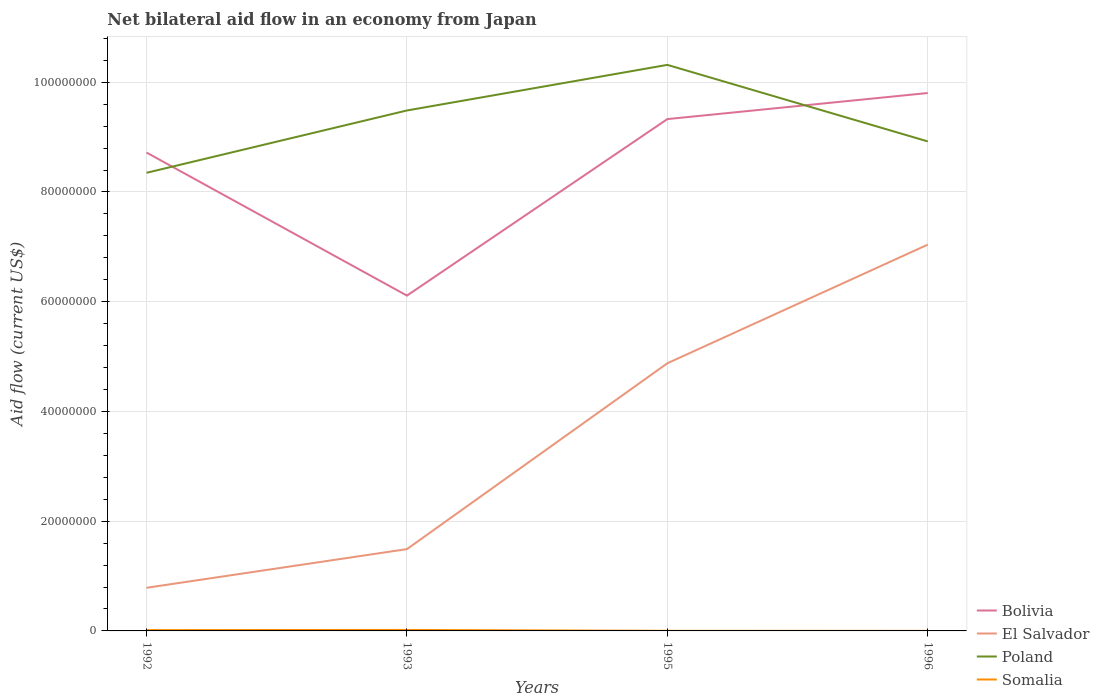Does the line corresponding to Poland intersect with the line corresponding to Bolivia?
Offer a terse response. Yes. Is the number of lines equal to the number of legend labels?
Make the answer very short. Yes. Across all years, what is the maximum net bilateral aid flow in Bolivia?
Provide a short and direct response. 6.11e+07. In which year was the net bilateral aid flow in El Salvador maximum?
Your answer should be compact. 1992. What is the total net bilateral aid flow in Bolivia in the graph?
Your response must be concise. 2.61e+07. What is the difference between the highest and the second highest net bilateral aid flow in Poland?
Your answer should be compact. 1.97e+07. How many lines are there?
Give a very brief answer. 4. Does the graph contain any zero values?
Your answer should be very brief. No. Does the graph contain grids?
Provide a succinct answer. Yes. Where does the legend appear in the graph?
Provide a succinct answer. Bottom right. How are the legend labels stacked?
Make the answer very short. Vertical. What is the title of the graph?
Provide a succinct answer. Net bilateral aid flow in an economy from Japan. What is the label or title of the X-axis?
Keep it short and to the point. Years. What is the label or title of the Y-axis?
Make the answer very short. Aid flow (current US$). What is the Aid flow (current US$) of Bolivia in 1992?
Your answer should be compact. 8.72e+07. What is the Aid flow (current US$) of El Salvador in 1992?
Provide a succinct answer. 7.86e+06. What is the Aid flow (current US$) of Poland in 1992?
Make the answer very short. 8.35e+07. What is the Aid flow (current US$) in Bolivia in 1993?
Provide a succinct answer. 6.11e+07. What is the Aid flow (current US$) in El Salvador in 1993?
Your answer should be compact. 1.49e+07. What is the Aid flow (current US$) in Poland in 1993?
Make the answer very short. 9.48e+07. What is the Aid flow (current US$) of Bolivia in 1995?
Give a very brief answer. 9.33e+07. What is the Aid flow (current US$) of El Salvador in 1995?
Your response must be concise. 4.88e+07. What is the Aid flow (current US$) of Poland in 1995?
Your answer should be very brief. 1.03e+08. What is the Aid flow (current US$) in Bolivia in 1996?
Ensure brevity in your answer.  9.80e+07. What is the Aid flow (current US$) in El Salvador in 1996?
Your answer should be compact. 7.04e+07. What is the Aid flow (current US$) of Poland in 1996?
Offer a terse response. 8.92e+07. Across all years, what is the maximum Aid flow (current US$) in Bolivia?
Offer a very short reply. 9.80e+07. Across all years, what is the maximum Aid flow (current US$) in El Salvador?
Make the answer very short. 7.04e+07. Across all years, what is the maximum Aid flow (current US$) of Poland?
Offer a terse response. 1.03e+08. Across all years, what is the minimum Aid flow (current US$) in Bolivia?
Your response must be concise. 6.11e+07. Across all years, what is the minimum Aid flow (current US$) in El Salvador?
Offer a very short reply. 7.86e+06. Across all years, what is the minimum Aid flow (current US$) in Poland?
Offer a very short reply. 8.35e+07. What is the total Aid flow (current US$) of Bolivia in the graph?
Your answer should be compact. 3.40e+08. What is the total Aid flow (current US$) of El Salvador in the graph?
Offer a terse response. 1.42e+08. What is the total Aid flow (current US$) in Poland in the graph?
Provide a succinct answer. 3.71e+08. What is the difference between the Aid flow (current US$) in Bolivia in 1992 and that in 1993?
Keep it short and to the point. 2.61e+07. What is the difference between the Aid flow (current US$) in El Salvador in 1992 and that in 1993?
Your answer should be very brief. -7.05e+06. What is the difference between the Aid flow (current US$) in Poland in 1992 and that in 1993?
Provide a short and direct response. -1.14e+07. What is the difference between the Aid flow (current US$) of Somalia in 1992 and that in 1993?
Provide a short and direct response. -3.00e+04. What is the difference between the Aid flow (current US$) of Bolivia in 1992 and that in 1995?
Provide a succinct answer. -6.10e+06. What is the difference between the Aid flow (current US$) of El Salvador in 1992 and that in 1995?
Offer a very short reply. -4.09e+07. What is the difference between the Aid flow (current US$) of Poland in 1992 and that in 1995?
Ensure brevity in your answer.  -1.97e+07. What is the difference between the Aid flow (current US$) in Bolivia in 1992 and that in 1996?
Offer a very short reply. -1.08e+07. What is the difference between the Aid flow (current US$) of El Salvador in 1992 and that in 1996?
Make the answer very short. -6.25e+07. What is the difference between the Aid flow (current US$) of Poland in 1992 and that in 1996?
Ensure brevity in your answer.  -5.72e+06. What is the difference between the Aid flow (current US$) of Bolivia in 1993 and that in 1995?
Give a very brief answer. -3.22e+07. What is the difference between the Aid flow (current US$) in El Salvador in 1993 and that in 1995?
Ensure brevity in your answer.  -3.39e+07. What is the difference between the Aid flow (current US$) of Poland in 1993 and that in 1995?
Your response must be concise. -8.31e+06. What is the difference between the Aid flow (current US$) in Somalia in 1993 and that in 1995?
Make the answer very short. 1.60e+05. What is the difference between the Aid flow (current US$) in Bolivia in 1993 and that in 1996?
Your answer should be compact. -3.69e+07. What is the difference between the Aid flow (current US$) in El Salvador in 1993 and that in 1996?
Offer a very short reply. -5.55e+07. What is the difference between the Aid flow (current US$) of Poland in 1993 and that in 1996?
Provide a short and direct response. 5.64e+06. What is the difference between the Aid flow (current US$) of Somalia in 1993 and that in 1996?
Ensure brevity in your answer.  1.70e+05. What is the difference between the Aid flow (current US$) in Bolivia in 1995 and that in 1996?
Offer a very short reply. -4.75e+06. What is the difference between the Aid flow (current US$) of El Salvador in 1995 and that in 1996?
Give a very brief answer. -2.16e+07. What is the difference between the Aid flow (current US$) of Poland in 1995 and that in 1996?
Offer a very short reply. 1.40e+07. What is the difference between the Aid flow (current US$) in Bolivia in 1992 and the Aid flow (current US$) in El Salvador in 1993?
Your response must be concise. 7.23e+07. What is the difference between the Aid flow (current US$) of Bolivia in 1992 and the Aid flow (current US$) of Poland in 1993?
Keep it short and to the point. -7.67e+06. What is the difference between the Aid flow (current US$) in Bolivia in 1992 and the Aid flow (current US$) in Somalia in 1993?
Make the answer very short. 8.70e+07. What is the difference between the Aid flow (current US$) in El Salvador in 1992 and the Aid flow (current US$) in Poland in 1993?
Your answer should be very brief. -8.70e+07. What is the difference between the Aid flow (current US$) in El Salvador in 1992 and the Aid flow (current US$) in Somalia in 1993?
Offer a very short reply. 7.68e+06. What is the difference between the Aid flow (current US$) in Poland in 1992 and the Aid flow (current US$) in Somalia in 1993?
Your answer should be compact. 8.33e+07. What is the difference between the Aid flow (current US$) of Bolivia in 1992 and the Aid flow (current US$) of El Salvador in 1995?
Ensure brevity in your answer.  3.84e+07. What is the difference between the Aid flow (current US$) of Bolivia in 1992 and the Aid flow (current US$) of Poland in 1995?
Your answer should be very brief. -1.60e+07. What is the difference between the Aid flow (current US$) of Bolivia in 1992 and the Aid flow (current US$) of Somalia in 1995?
Provide a succinct answer. 8.72e+07. What is the difference between the Aid flow (current US$) in El Salvador in 1992 and the Aid flow (current US$) in Poland in 1995?
Provide a short and direct response. -9.53e+07. What is the difference between the Aid flow (current US$) in El Salvador in 1992 and the Aid flow (current US$) in Somalia in 1995?
Your answer should be very brief. 7.84e+06. What is the difference between the Aid flow (current US$) in Poland in 1992 and the Aid flow (current US$) in Somalia in 1995?
Offer a terse response. 8.35e+07. What is the difference between the Aid flow (current US$) of Bolivia in 1992 and the Aid flow (current US$) of El Salvador in 1996?
Provide a succinct answer. 1.68e+07. What is the difference between the Aid flow (current US$) of Bolivia in 1992 and the Aid flow (current US$) of Poland in 1996?
Provide a succinct answer. -2.03e+06. What is the difference between the Aid flow (current US$) in Bolivia in 1992 and the Aid flow (current US$) in Somalia in 1996?
Your answer should be very brief. 8.72e+07. What is the difference between the Aid flow (current US$) in El Salvador in 1992 and the Aid flow (current US$) in Poland in 1996?
Make the answer very short. -8.14e+07. What is the difference between the Aid flow (current US$) in El Salvador in 1992 and the Aid flow (current US$) in Somalia in 1996?
Offer a very short reply. 7.85e+06. What is the difference between the Aid flow (current US$) in Poland in 1992 and the Aid flow (current US$) in Somalia in 1996?
Offer a terse response. 8.35e+07. What is the difference between the Aid flow (current US$) in Bolivia in 1993 and the Aid flow (current US$) in El Salvador in 1995?
Your answer should be very brief. 1.23e+07. What is the difference between the Aid flow (current US$) in Bolivia in 1993 and the Aid flow (current US$) in Poland in 1995?
Provide a short and direct response. -4.20e+07. What is the difference between the Aid flow (current US$) of Bolivia in 1993 and the Aid flow (current US$) of Somalia in 1995?
Provide a succinct answer. 6.11e+07. What is the difference between the Aid flow (current US$) in El Salvador in 1993 and the Aid flow (current US$) in Poland in 1995?
Ensure brevity in your answer.  -8.82e+07. What is the difference between the Aid flow (current US$) in El Salvador in 1993 and the Aid flow (current US$) in Somalia in 1995?
Your answer should be compact. 1.49e+07. What is the difference between the Aid flow (current US$) in Poland in 1993 and the Aid flow (current US$) in Somalia in 1995?
Provide a short and direct response. 9.48e+07. What is the difference between the Aid flow (current US$) of Bolivia in 1993 and the Aid flow (current US$) of El Salvador in 1996?
Offer a very short reply. -9.29e+06. What is the difference between the Aid flow (current US$) in Bolivia in 1993 and the Aid flow (current US$) in Poland in 1996?
Your answer should be compact. -2.81e+07. What is the difference between the Aid flow (current US$) of Bolivia in 1993 and the Aid flow (current US$) of Somalia in 1996?
Give a very brief answer. 6.11e+07. What is the difference between the Aid flow (current US$) of El Salvador in 1993 and the Aid flow (current US$) of Poland in 1996?
Ensure brevity in your answer.  -7.43e+07. What is the difference between the Aid flow (current US$) of El Salvador in 1993 and the Aid flow (current US$) of Somalia in 1996?
Keep it short and to the point. 1.49e+07. What is the difference between the Aid flow (current US$) of Poland in 1993 and the Aid flow (current US$) of Somalia in 1996?
Ensure brevity in your answer.  9.48e+07. What is the difference between the Aid flow (current US$) in Bolivia in 1995 and the Aid flow (current US$) in El Salvador in 1996?
Your response must be concise. 2.29e+07. What is the difference between the Aid flow (current US$) of Bolivia in 1995 and the Aid flow (current US$) of Poland in 1996?
Make the answer very short. 4.07e+06. What is the difference between the Aid flow (current US$) in Bolivia in 1995 and the Aid flow (current US$) in Somalia in 1996?
Keep it short and to the point. 9.33e+07. What is the difference between the Aid flow (current US$) of El Salvador in 1995 and the Aid flow (current US$) of Poland in 1996?
Provide a short and direct response. -4.04e+07. What is the difference between the Aid flow (current US$) of El Salvador in 1995 and the Aid flow (current US$) of Somalia in 1996?
Your response must be concise. 4.88e+07. What is the difference between the Aid flow (current US$) in Poland in 1995 and the Aid flow (current US$) in Somalia in 1996?
Provide a short and direct response. 1.03e+08. What is the average Aid flow (current US$) of Bolivia per year?
Offer a terse response. 8.49e+07. What is the average Aid flow (current US$) of El Salvador per year?
Your answer should be compact. 3.55e+07. What is the average Aid flow (current US$) in Poland per year?
Your answer should be compact. 9.27e+07. What is the average Aid flow (current US$) in Somalia per year?
Ensure brevity in your answer.  9.00e+04. In the year 1992, what is the difference between the Aid flow (current US$) of Bolivia and Aid flow (current US$) of El Salvador?
Give a very brief answer. 7.93e+07. In the year 1992, what is the difference between the Aid flow (current US$) of Bolivia and Aid flow (current US$) of Poland?
Your response must be concise. 3.69e+06. In the year 1992, what is the difference between the Aid flow (current US$) in Bolivia and Aid flow (current US$) in Somalia?
Your answer should be very brief. 8.70e+07. In the year 1992, what is the difference between the Aid flow (current US$) of El Salvador and Aid flow (current US$) of Poland?
Your answer should be very brief. -7.56e+07. In the year 1992, what is the difference between the Aid flow (current US$) in El Salvador and Aid flow (current US$) in Somalia?
Keep it short and to the point. 7.71e+06. In the year 1992, what is the difference between the Aid flow (current US$) in Poland and Aid flow (current US$) in Somalia?
Your response must be concise. 8.33e+07. In the year 1993, what is the difference between the Aid flow (current US$) in Bolivia and Aid flow (current US$) in El Salvador?
Provide a short and direct response. 4.62e+07. In the year 1993, what is the difference between the Aid flow (current US$) of Bolivia and Aid flow (current US$) of Poland?
Your answer should be very brief. -3.37e+07. In the year 1993, what is the difference between the Aid flow (current US$) in Bolivia and Aid flow (current US$) in Somalia?
Ensure brevity in your answer.  6.09e+07. In the year 1993, what is the difference between the Aid flow (current US$) of El Salvador and Aid flow (current US$) of Poland?
Offer a terse response. -7.99e+07. In the year 1993, what is the difference between the Aid flow (current US$) in El Salvador and Aid flow (current US$) in Somalia?
Your answer should be very brief. 1.47e+07. In the year 1993, what is the difference between the Aid flow (current US$) in Poland and Aid flow (current US$) in Somalia?
Ensure brevity in your answer.  9.47e+07. In the year 1995, what is the difference between the Aid flow (current US$) of Bolivia and Aid flow (current US$) of El Salvador?
Your answer should be very brief. 4.45e+07. In the year 1995, what is the difference between the Aid flow (current US$) of Bolivia and Aid flow (current US$) of Poland?
Ensure brevity in your answer.  -9.88e+06. In the year 1995, what is the difference between the Aid flow (current US$) in Bolivia and Aid flow (current US$) in Somalia?
Keep it short and to the point. 9.33e+07. In the year 1995, what is the difference between the Aid flow (current US$) of El Salvador and Aid flow (current US$) of Poland?
Provide a succinct answer. -5.44e+07. In the year 1995, what is the difference between the Aid flow (current US$) of El Salvador and Aid flow (current US$) of Somalia?
Give a very brief answer. 4.88e+07. In the year 1995, what is the difference between the Aid flow (current US$) of Poland and Aid flow (current US$) of Somalia?
Offer a very short reply. 1.03e+08. In the year 1996, what is the difference between the Aid flow (current US$) in Bolivia and Aid flow (current US$) in El Salvador?
Give a very brief answer. 2.76e+07. In the year 1996, what is the difference between the Aid flow (current US$) in Bolivia and Aid flow (current US$) in Poland?
Give a very brief answer. 8.82e+06. In the year 1996, what is the difference between the Aid flow (current US$) in Bolivia and Aid flow (current US$) in Somalia?
Provide a succinct answer. 9.80e+07. In the year 1996, what is the difference between the Aid flow (current US$) of El Salvador and Aid flow (current US$) of Poland?
Your answer should be compact. -1.88e+07. In the year 1996, what is the difference between the Aid flow (current US$) of El Salvador and Aid flow (current US$) of Somalia?
Keep it short and to the point. 7.04e+07. In the year 1996, what is the difference between the Aid flow (current US$) in Poland and Aid flow (current US$) in Somalia?
Offer a very short reply. 8.92e+07. What is the ratio of the Aid flow (current US$) of Bolivia in 1992 to that in 1993?
Provide a succinct answer. 1.43. What is the ratio of the Aid flow (current US$) of El Salvador in 1992 to that in 1993?
Your answer should be compact. 0.53. What is the ratio of the Aid flow (current US$) in Poland in 1992 to that in 1993?
Your response must be concise. 0.88. What is the ratio of the Aid flow (current US$) of Bolivia in 1992 to that in 1995?
Keep it short and to the point. 0.93. What is the ratio of the Aid flow (current US$) in El Salvador in 1992 to that in 1995?
Offer a terse response. 0.16. What is the ratio of the Aid flow (current US$) of Poland in 1992 to that in 1995?
Provide a short and direct response. 0.81. What is the ratio of the Aid flow (current US$) in Bolivia in 1992 to that in 1996?
Offer a very short reply. 0.89. What is the ratio of the Aid flow (current US$) in El Salvador in 1992 to that in 1996?
Offer a very short reply. 0.11. What is the ratio of the Aid flow (current US$) in Poland in 1992 to that in 1996?
Your response must be concise. 0.94. What is the ratio of the Aid flow (current US$) of Bolivia in 1993 to that in 1995?
Offer a very short reply. 0.66. What is the ratio of the Aid flow (current US$) of El Salvador in 1993 to that in 1995?
Your response must be concise. 0.31. What is the ratio of the Aid flow (current US$) in Poland in 1993 to that in 1995?
Your response must be concise. 0.92. What is the ratio of the Aid flow (current US$) in Bolivia in 1993 to that in 1996?
Provide a succinct answer. 0.62. What is the ratio of the Aid flow (current US$) of El Salvador in 1993 to that in 1996?
Offer a terse response. 0.21. What is the ratio of the Aid flow (current US$) in Poland in 1993 to that in 1996?
Your response must be concise. 1.06. What is the ratio of the Aid flow (current US$) of Somalia in 1993 to that in 1996?
Offer a terse response. 18. What is the ratio of the Aid flow (current US$) of Bolivia in 1995 to that in 1996?
Your answer should be very brief. 0.95. What is the ratio of the Aid flow (current US$) of El Salvador in 1995 to that in 1996?
Give a very brief answer. 0.69. What is the ratio of the Aid flow (current US$) of Poland in 1995 to that in 1996?
Offer a terse response. 1.16. What is the difference between the highest and the second highest Aid flow (current US$) of Bolivia?
Provide a succinct answer. 4.75e+06. What is the difference between the highest and the second highest Aid flow (current US$) in El Salvador?
Your response must be concise. 2.16e+07. What is the difference between the highest and the second highest Aid flow (current US$) of Poland?
Your answer should be compact. 8.31e+06. What is the difference between the highest and the lowest Aid flow (current US$) in Bolivia?
Make the answer very short. 3.69e+07. What is the difference between the highest and the lowest Aid flow (current US$) of El Salvador?
Give a very brief answer. 6.25e+07. What is the difference between the highest and the lowest Aid flow (current US$) in Poland?
Give a very brief answer. 1.97e+07. 